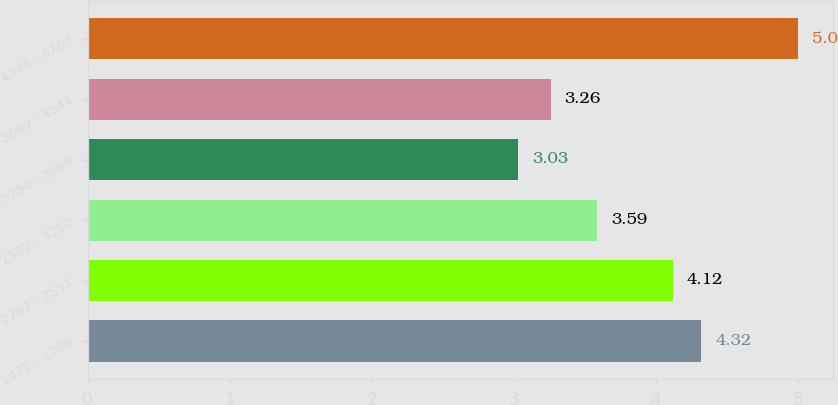Convert chart to OTSL. <chart><loc_0><loc_0><loc_500><loc_500><bar_chart><fcel>1471 - 2286<fcel>2287 - 2551<fcel>2552 - 3253<fcel>3254 - 3688<fcel>3689 - 4344<fcel>4345 - 4763<nl><fcel>4.32<fcel>4.12<fcel>3.59<fcel>3.03<fcel>3.26<fcel>5<nl></chart> 